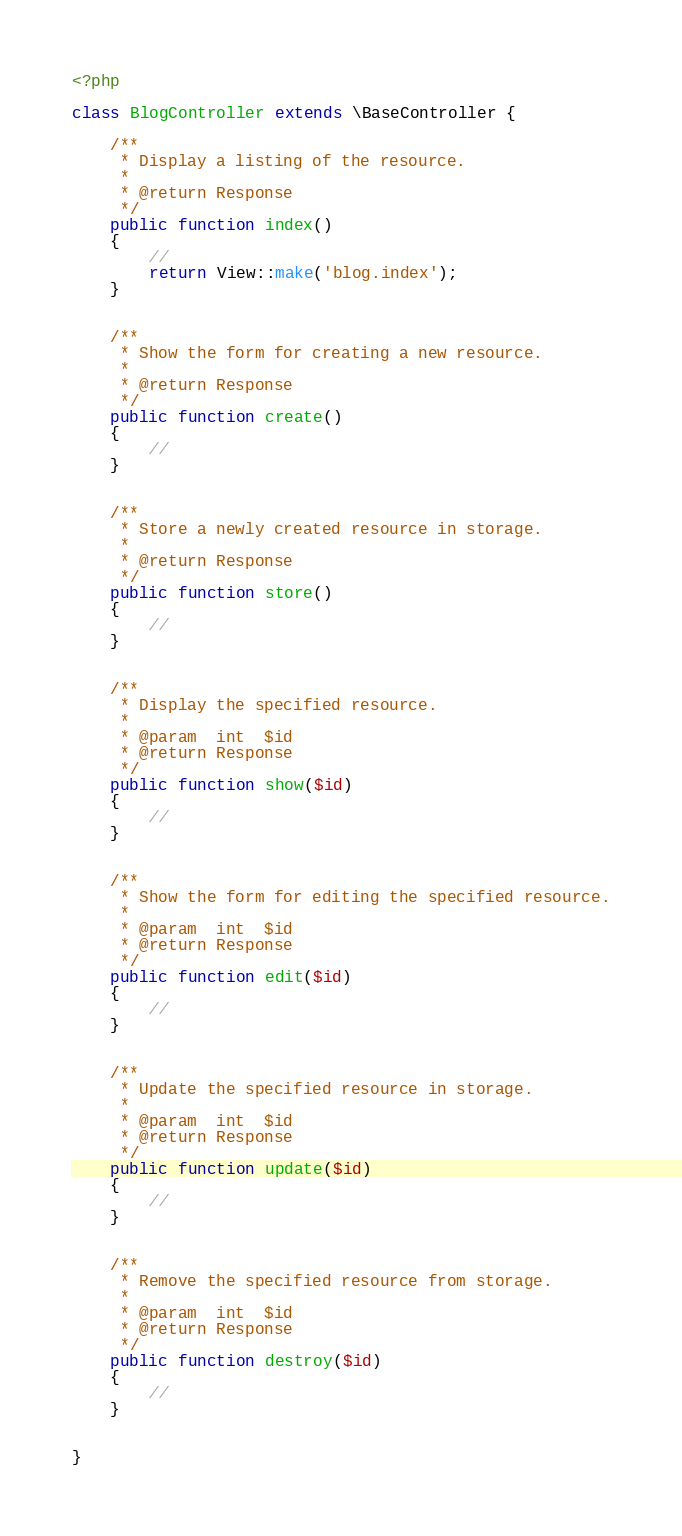<code> <loc_0><loc_0><loc_500><loc_500><_PHP_><?php

class BlogController extends \BaseController {

	/**
	 * Display a listing of the resource.
	 *
	 * @return Response
	 */
	public function index()
	{
		//
        return View::make('blog.index');
	}


	/**
	 * Show the form for creating a new resource.
	 *
	 * @return Response
	 */
	public function create()
	{
		//
	}


	/**
	 * Store a newly created resource in storage.
	 *
	 * @return Response
	 */
	public function store()
	{
		//
	}


	/**
	 * Display the specified resource.
	 *
	 * @param  int  $id
	 * @return Response
	 */
	public function show($id)
	{
		//
	}


	/**
	 * Show the form for editing the specified resource.
	 *
	 * @param  int  $id
	 * @return Response
	 */
	public function edit($id)
	{
		//
	}


	/**
	 * Update the specified resource in storage.
	 *
	 * @param  int  $id
	 * @return Response
	 */
	public function update($id)
	{
		//
	}


	/**
	 * Remove the specified resource from storage.
	 *
	 * @param  int  $id
	 * @return Response
	 */
	public function destroy($id)
	{
		//
	}


}
</code> 